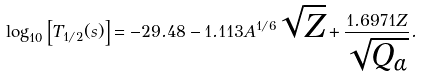<formula> <loc_0><loc_0><loc_500><loc_500>\log _ { 1 0 } \left [ T _ { 1 / 2 } ( s ) \right ] = - 2 9 . 4 8 - 1 . 1 1 3 A ^ { 1 / 6 } \sqrt { Z } + \frac { 1 . 6 9 7 1 Z } { \sqrt { Q _ { \alpha } } } .</formula> 